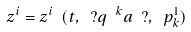<formula> <loc_0><loc_0><loc_500><loc_500>z ^ { i } = z ^ { i } \ ( t , \ ? q \ ^ { k } _ { \ } a \ ? , \ p ^ { 1 } _ { k } )</formula> 